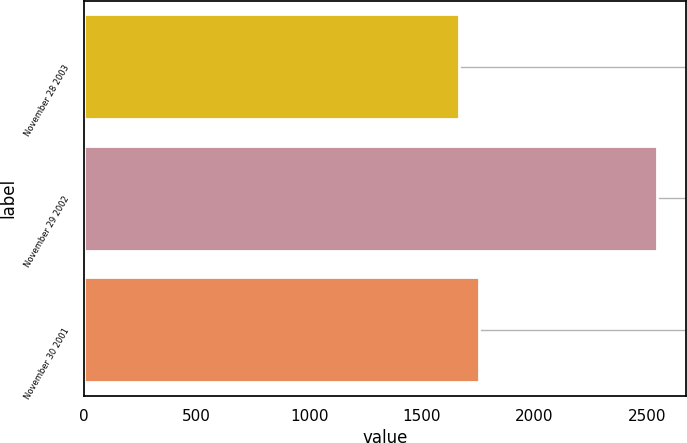<chart> <loc_0><loc_0><loc_500><loc_500><bar_chart><fcel>November 28 2003<fcel>November 29 2002<fcel>November 30 2001<nl><fcel>1666<fcel>2545<fcel>1753.9<nl></chart> 